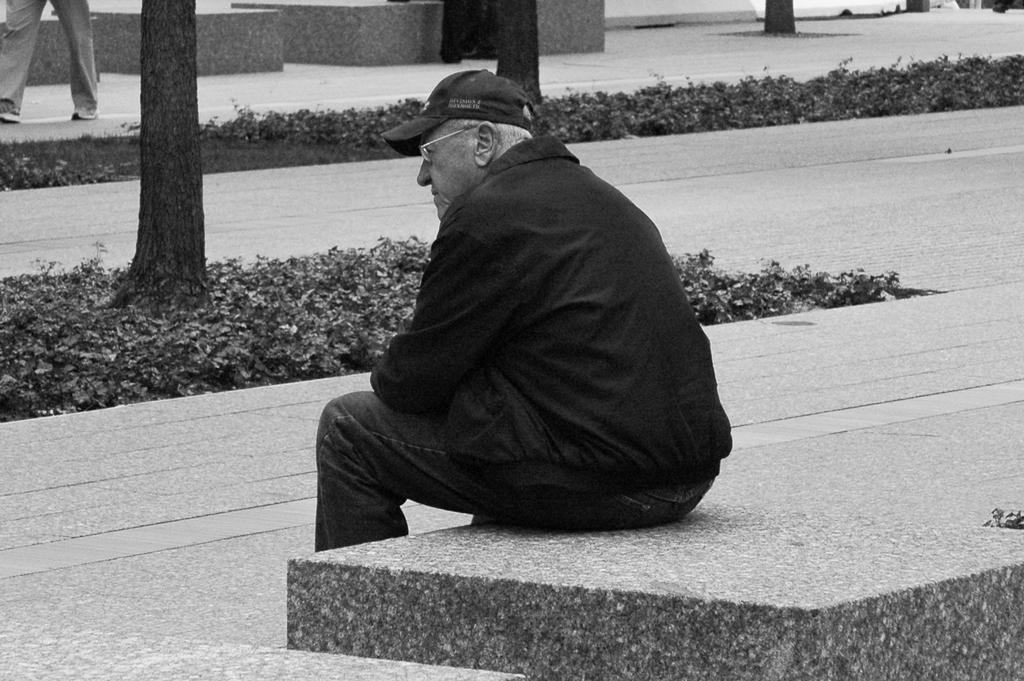How many people are present in the image? There are two persons in the image. What is the position of one of the persons? One person is sitting on a surface. What type of vegetation can be seen in the image? There are plants and tree trunks in the image. What is the color scheme of the image? The image is in black and white mode. Can you see any worms crawling on the tree trunks in the image? There are no worms visible in the image; it only features plants and tree trunks. Is the image a print or a digital photograph? The information provided does not specify whether the image is a print or a digital photograph. 